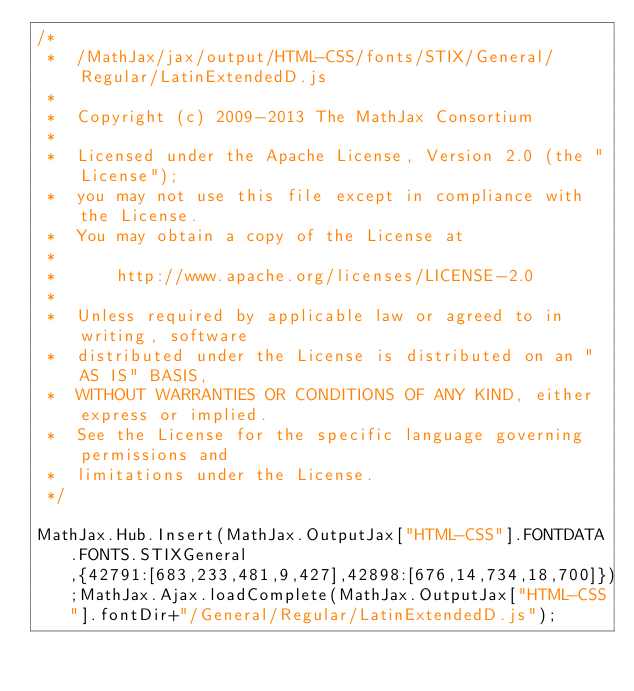Convert code to text. <code><loc_0><loc_0><loc_500><loc_500><_JavaScript_>/*
 *  /MathJax/jax/output/HTML-CSS/fonts/STIX/General/Regular/LatinExtendedD.js
 *
 *  Copyright (c) 2009-2013 The MathJax Consortium
 *
 *  Licensed under the Apache License, Version 2.0 (the "License");
 *  you may not use this file except in compliance with the License.
 *  You may obtain a copy of the License at
 *
 *      http://www.apache.org/licenses/LICENSE-2.0
 *
 *  Unless required by applicable law or agreed to in writing, software
 *  distributed under the License is distributed on an "AS IS" BASIS,
 *  WITHOUT WARRANTIES OR CONDITIONS OF ANY KIND, either express or implied.
 *  See the License for the specific language governing permissions and
 *  limitations under the License.
 */

MathJax.Hub.Insert(MathJax.OutputJax["HTML-CSS"].FONTDATA.FONTS.STIXGeneral,{42791:[683,233,481,9,427],42898:[676,14,734,18,700]});MathJax.Ajax.loadComplete(MathJax.OutputJax["HTML-CSS"].fontDir+"/General/Regular/LatinExtendedD.js");
</code> 